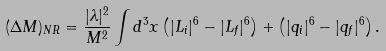Convert formula to latex. <formula><loc_0><loc_0><loc_500><loc_500>( \Delta M ) _ { N R } = \frac { | \lambda | ^ { 2 } } { M ^ { 2 } } \int d ^ { 3 } x \left ( | L _ { i } | ^ { 6 } - | L _ { f } | ^ { 6 } \right ) + \left ( | q _ { i } | ^ { 6 } - | q _ { f } | ^ { 6 } \right ) .</formula> 